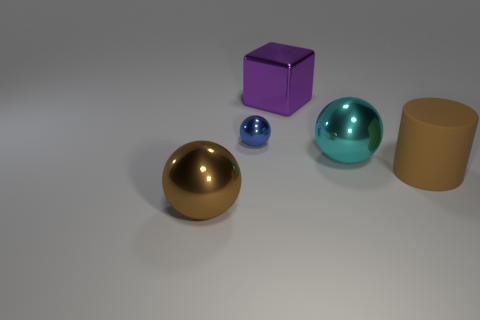Subtract all big metallic spheres. How many spheres are left? 1 Subtract 1 spheres. How many spheres are left? 2 Add 2 small cyan metal cylinders. How many objects exist? 7 Subtract all gray balls. Subtract all purple cylinders. How many balls are left? 3 Add 4 large purple objects. How many large purple objects exist? 5 Subtract 0 gray cubes. How many objects are left? 5 Subtract all cubes. How many objects are left? 4 Subtract all large brown metal objects. Subtract all metallic objects. How many objects are left? 0 Add 4 large rubber things. How many large rubber things are left? 5 